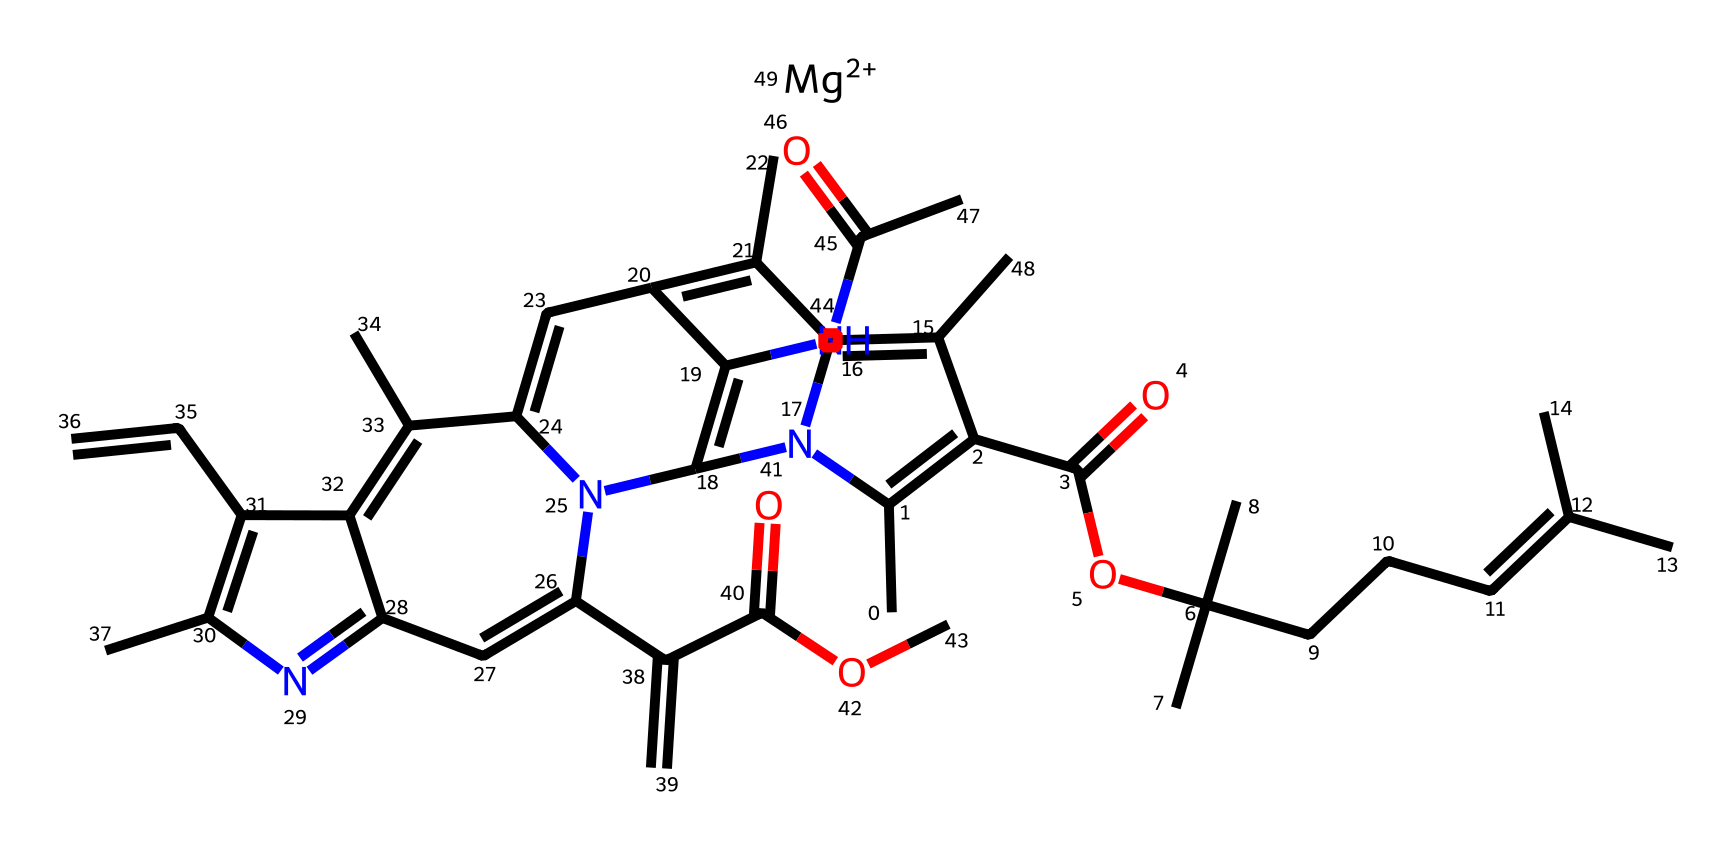What type of chemical is this? This chemical is classified as a photoreactive compound, specifically related to the structure of chlorophyll involved in photosynthesis. Photoreactive chemicals are sensitive to light, allowing them to participate in light absorption processes.
Answer: photoreactive compound How many nitrogen atoms are present in the structure? To determine the number of nitrogen atoms, we can examine the SMILES representation. The symbol 'N' represents nitrogen, and by counting the total occurrences, we find there are four nitrogen atoms in the structure.
Answer: four What is the main functional group present in this compound? Analyzing the structure, we look for the presence of functional groups, which are specific groups of atoms responsible for the chemical properties of the molecule. Here, we see an ester group and possibly amide groups due to the carbonyl (C=O) and nitrogen presence. The most prominent here is the ester formed by the C(=O)OC part.
Answer: ester What role does magnesium play in this chemical? In the context of chlorophyll, magnesium serves as a central atom in the porphyrin ring structure, facilitating light absorption and energy transfer during photosynthesis. Its presence is critical for the photoreactivity of the compound in capturing light energy.
Answer: central atom How many carbon atoms are in this compound? Counting the carbon atoms involves identifying each carbon symbol 'C' in the SMILES representation. By systematically counting these, we find that there are 29 carbon atoms in total in the structure.
Answer: twenty-nine What is the molecular formula representation of this compound? To derive the molecular formula from the SMILES code, we traditionally summarize the counts of each atom type. After analyzing the entire structure, the molecular formula can be deduced as C29H42N4O4Mg.
Answer: C29H42N4O4Mg 